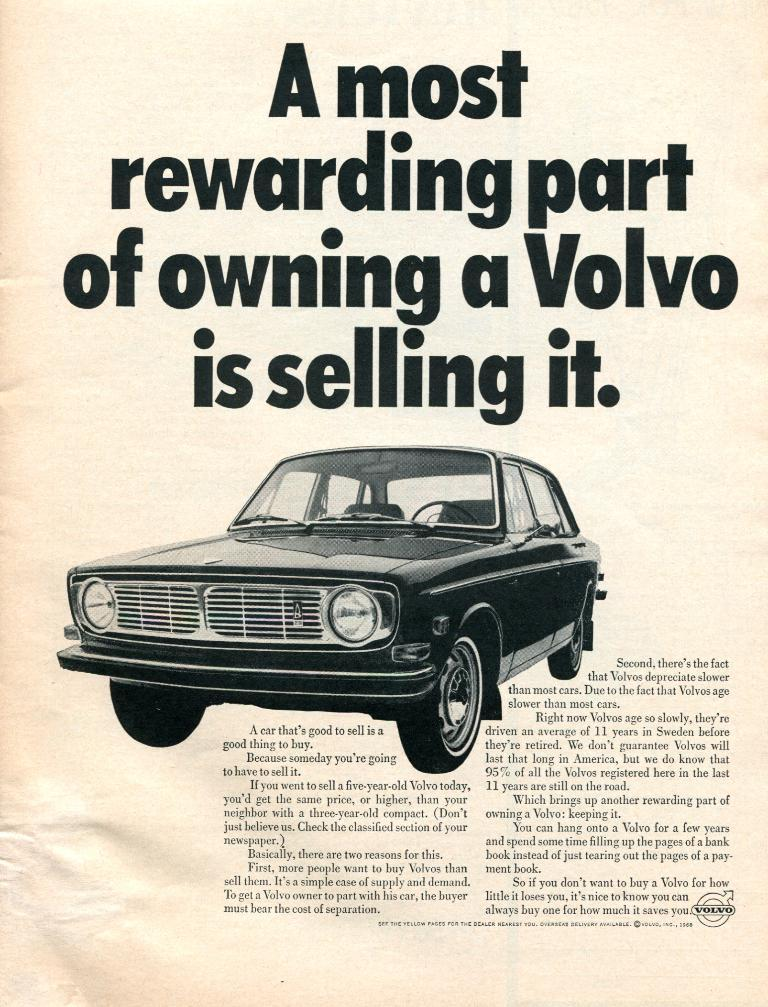What is present in the image that contains both text and an image? There is a poster in the image that contains text and an image. Can you describe the content of the poster? The poster contains text and an image, but the specific content cannot be determined from the provided facts. Where is the parcel being delivered in the image? There is no parcel present in the image. What type of dinner is being served in the image? There is no dinner present in the image. 